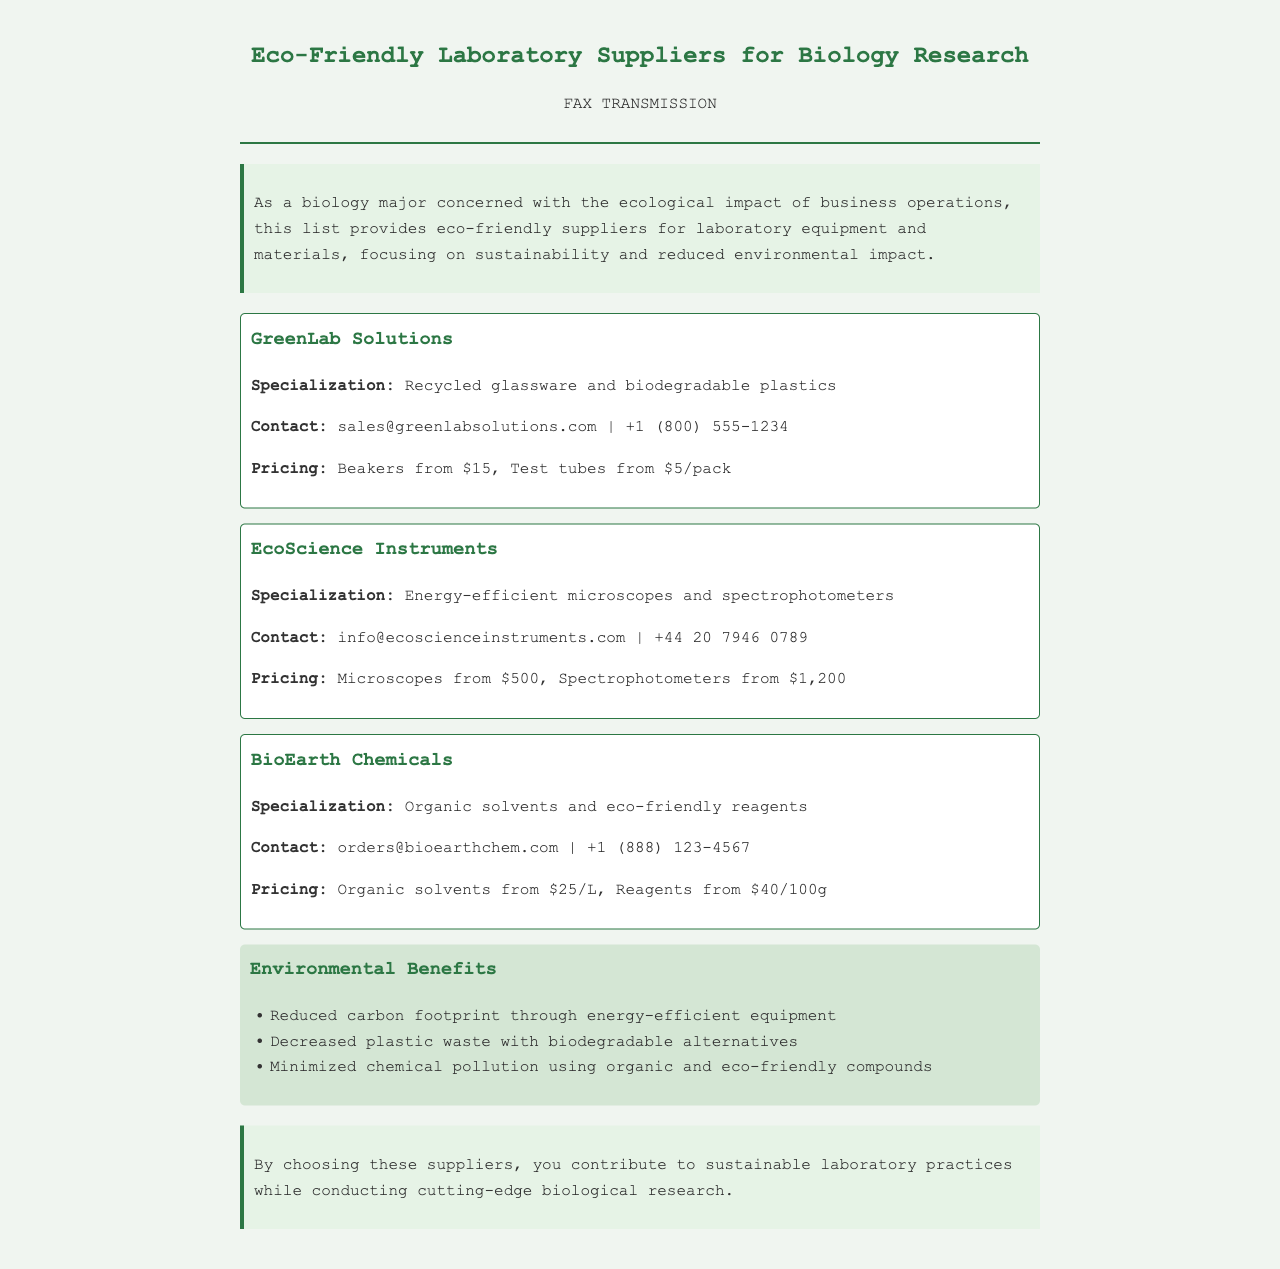What is the name of the first supplier? The first supplier listed in the document is named "GreenLab Solutions".
Answer: GreenLab Solutions What specialization does EcoScience Instruments focus on? EcoScience Instruments specializes in "Energy-efficient microscopes and spectrophotometers".
Answer: Energy-efficient microscopes and spectrophotometers What are the starting prices for beakers from GreenLab Solutions? The document states the starting prices for beakers from GreenLab Solutions as "$15".
Answer: $15 What is the contact email for BioEarth Chemicals? The contact email provided for BioEarth Chemicals is "orders@bioearthchem.com".
Answer: orders@bioearthchem.com What is one of the environmental benefits listed in the document? The document lists several environmental benefits, one of which is "Reduced carbon footprint through energy-efficient equipment".
Answer: Reduced carbon footprint through energy-efficient equipment How much do microscopes from EcoScience Instruments start at? According to the document, microscopes from EcoScience Instruments start at "$500".
Answer: $500 What is the contact number for GreenLab Solutions? The contact number provided for GreenLab Solutions is "+1 (800) 555-1234".
Answer: +1 (800) 555-1234 What type of document is this fax classified as? This document is classified as a transmission of a list of eco-friendly suppliers specifically for laboratories.
Answer: Fax transmission What is the specialization of BioEarth Chemicals? BioEarth Chemicals specializes in "Organic solvents and eco-friendly reagents".
Answer: Organic solvents and eco-friendly reagents 